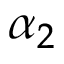<formula> <loc_0><loc_0><loc_500><loc_500>\alpha _ { 2 }</formula> 